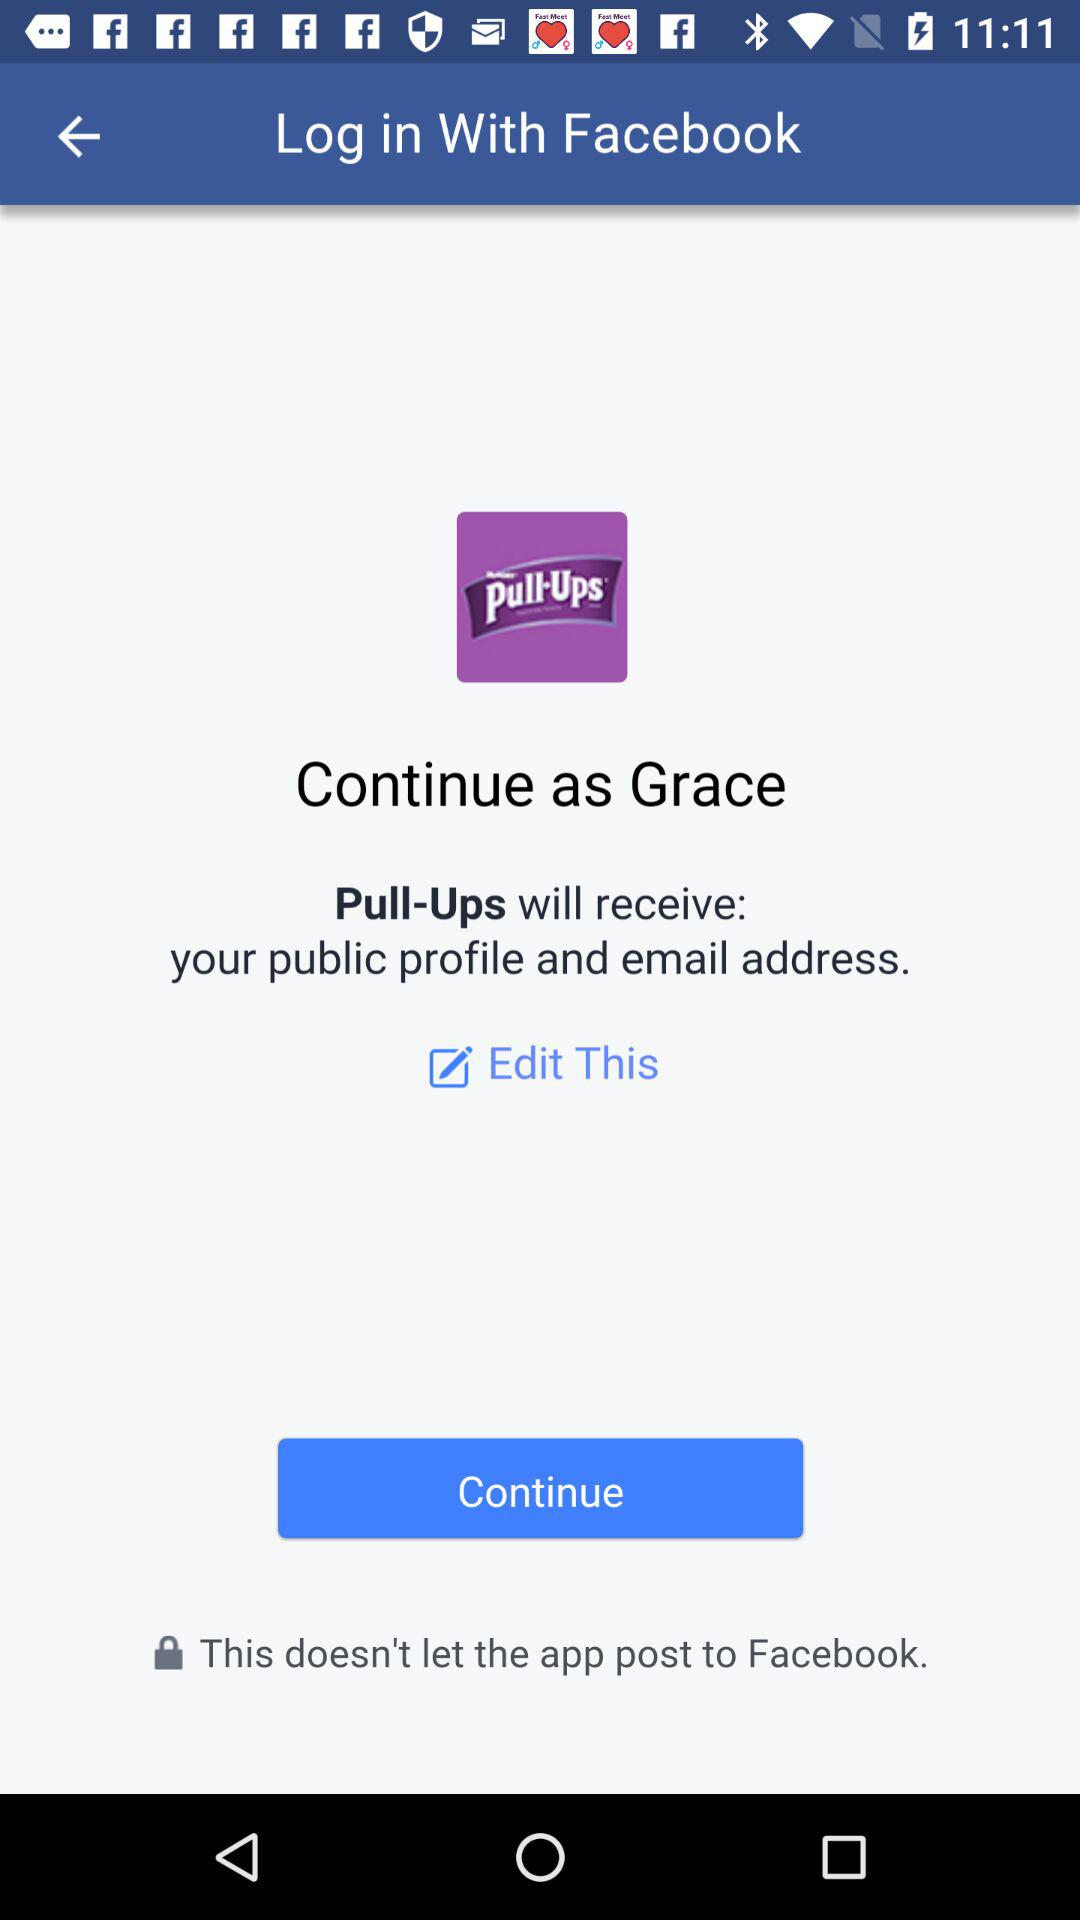How many profile details does Pull-Ups receive?
Answer the question using a single word or phrase. 2 